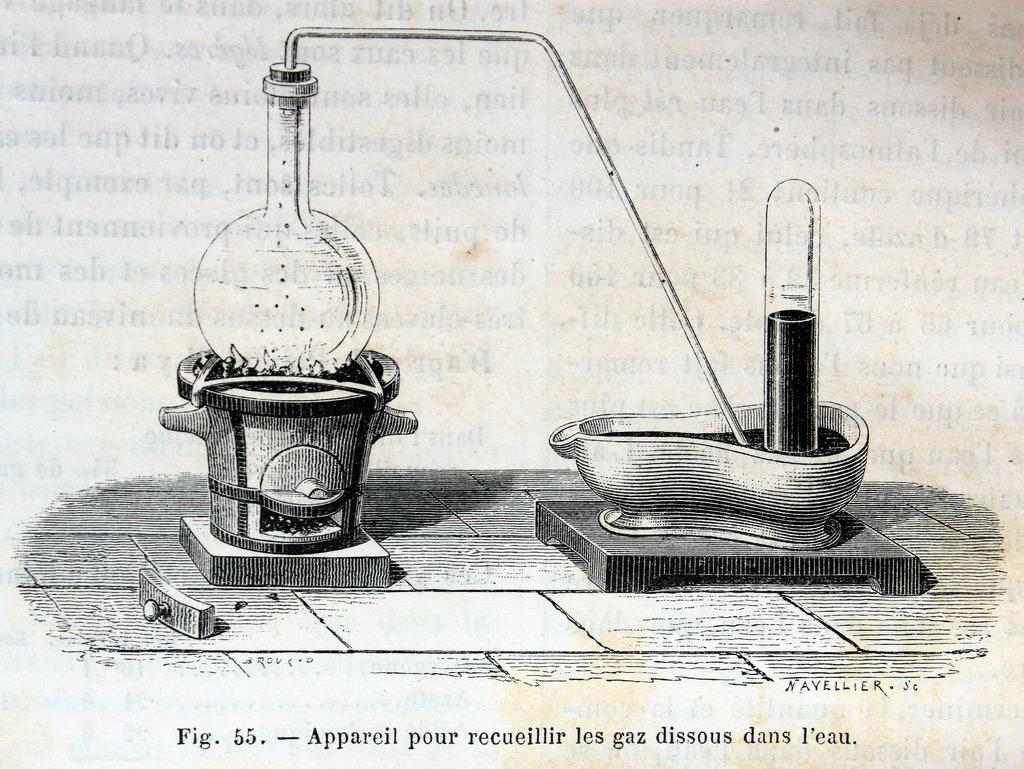Provide a one-sentence caption for the provided image. Figure 55 is a drawing of a chemistry experiment. 